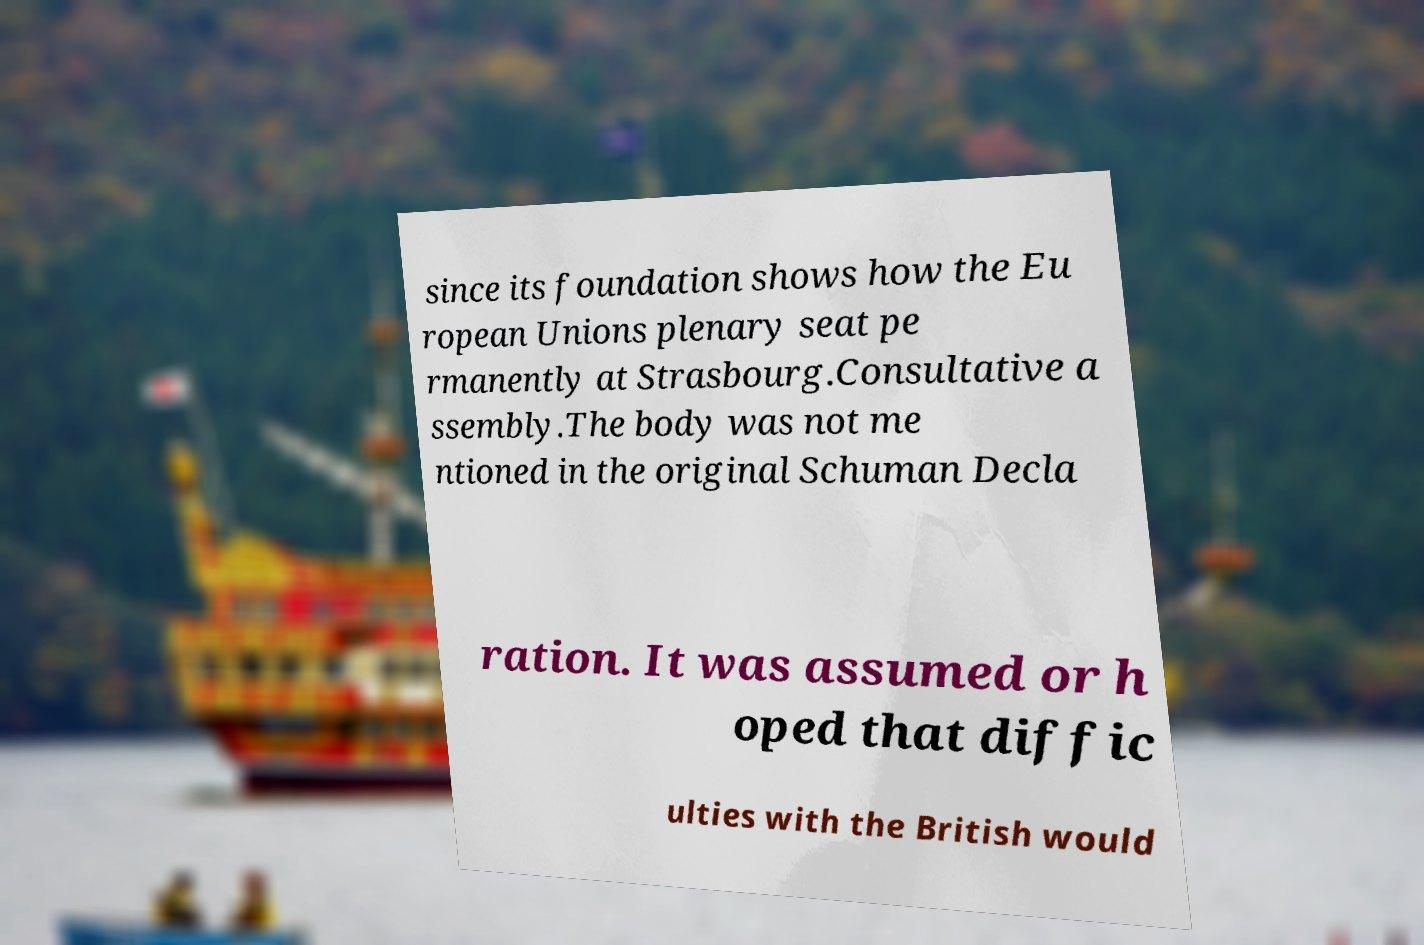Please identify and transcribe the text found in this image. since its foundation shows how the Eu ropean Unions plenary seat pe rmanently at Strasbourg.Consultative a ssembly.The body was not me ntioned in the original Schuman Decla ration. It was assumed or h oped that diffic ulties with the British would 